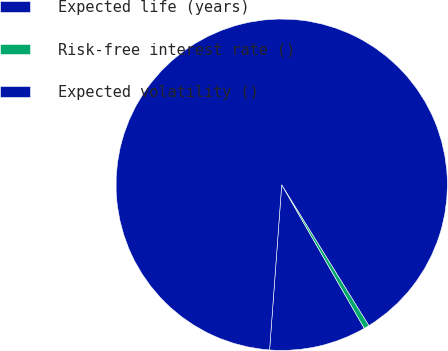Convert chart to OTSL. <chart><loc_0><loc_0><loc_500><loc_500><pie_chart><fcel>Expected life (years)<fcel>Risk-free interest rate ()<fcel>Expected volatility ()<nl><fcel>9.47%<fcel>0.52%<fcel>90.01%<nl></chart> 